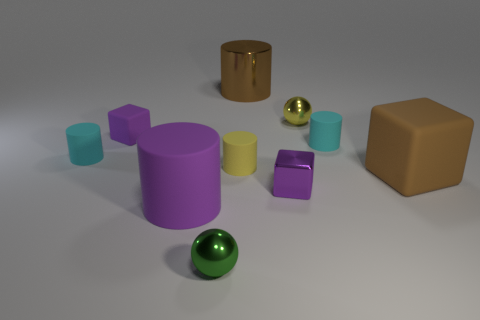What is the shape of the large thing that is the same color as the small shiny block?
Keep it short and to the point. Cylinder. There is a cylinder that is in front of the large brown rubber thing; what material is it?
Provide a short and direct response. Rubber. Do the brown cylinder and the yellow matte thing have the same size?
Offer a very short reply. No. Are there more big objects that are in front of the tiny purple shiny block than purple rubber cylinders?
Make the answer very short. No. There is a green thing that is the same material as the yellow ball; what size is it?
Keep it short and to the point. Small. Are there any cyan objects in front of the large brown rubber cube?
Your answer should be compact. No. Do the purple metal thing and the small yellow rubber object have the same shape?
Your answer should be very brief. No. What is the size of the matte block behind the cyan rubber cylinder right of the tiny cube that is behind the yellow matte cylinder?
Keep it short and to the point. Small. What is the green sphere made of?
Your answer should be compact. Metal. The metallic cube that is the same color as the tiny matte cube is what size?
Your answer should be very brief. Small. 